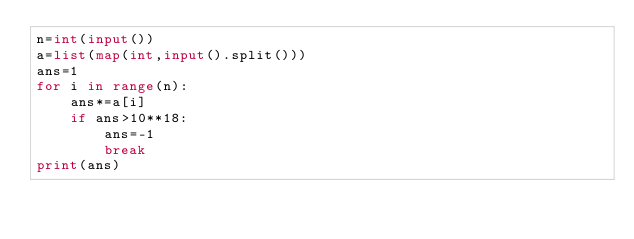Convert code to text. <code><loc_0><loc_0><loc_500><loc_500><_Python_>n=int(input())
a=list(map(int,input().split()))
ans=1
for i in range(n):
    ans*=a[i]
    if ans>10**18:
        ans=-1
        break
print(ans)</code> 